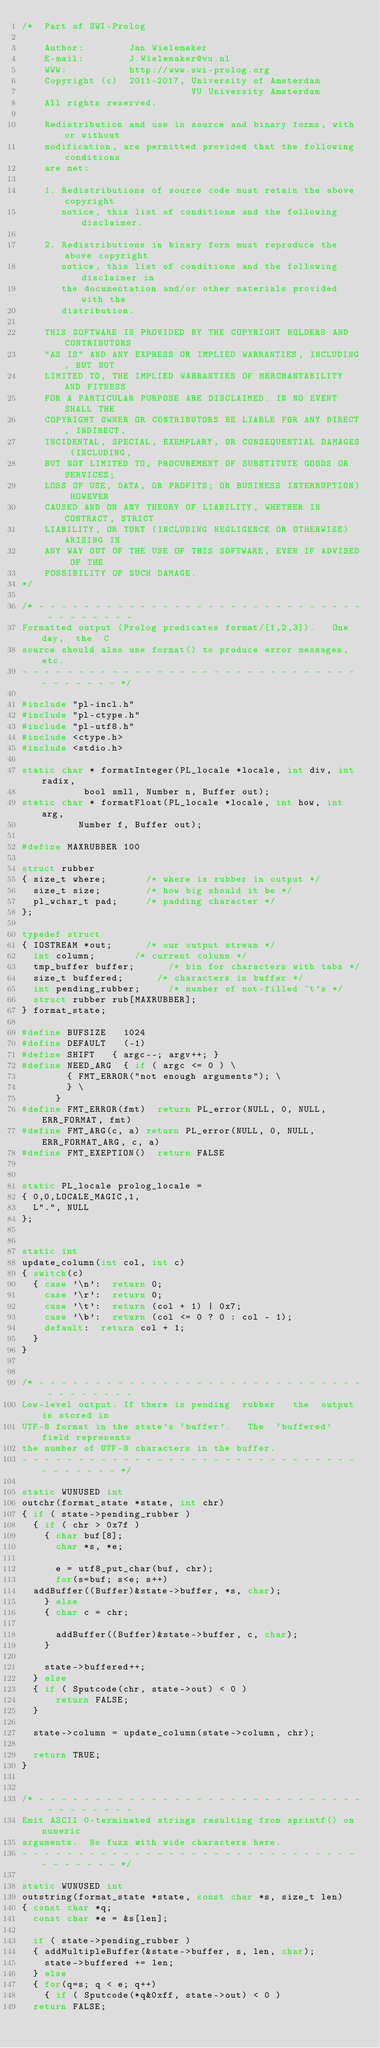Convert code to text. <code><loc_0><loc_0><loc_500><loc_500><_C_>/*  Part of SWI-Prolog

    Author:        Jan Wielemaker
    E-mail:        J.Wielemaker@vu.nl
    WWW:           http://www.swi-prolog.org
    Copyright (c)  2011-2017, University of Amsterdam
                              VU University Amsterdam
    All rights reserved.

    Redistribution and use in source and binary forms, with or without
    modification, are permitted provided that the following conditions
    are met:

    1. Redistributions of source code must retain the above copyright
       notice, this list of conditions and the following disclaimer.

    2. Redistributions in binary form must reproduce the above copyright
       notice, this list of conditions and the following disclaimer in
       the documentation and/or other materials provided with the
       distribution.

    THIS SOFTWARE IS PROVIDED BY THE COPYRIGHT HOLDERS AND CONTRIBUTORS
    "AS IS" AND ANY EXPRESS OR IMPLIED WARRANTIES, INCLUDING, BUT NOT
    LIMITED TO, THE IMPLIED WARRANTIES OF MERCHANTABILITY AND FITNESS
    FOR A PARTICULAR PURPOSE ARE DISCLAIMED. IN NO EVENT SHALL THE
    COPYRIGHT OWNER OR CONTRIBUTORS BE LIABLE FOR ANY DIRECT, INDIRECT,
    INCIDENTAL, SPECIAL, EXEMPLARY, OR CONSEQUENTIAL DAMAGES (INCLUDING,
    BUT NOT LIMITED TO, PROCUREMENT OF SUBSTITUTE GOODS OR SERVICES;
    LOSS OF USE, DATA, OR PROFITS; OR BUSINESS INTERRUPTION) HOWEVER
    CAUSED AND ON ANY THEORY OF LIABILITY, WHETHER IN CONTRACT, STRICT
    LIABILITY, OR TORT (INCLUDING NEGLIGENCE OR OTHERWISE) ARISING IN
    ANY WAY OUT OF THE USE OF THIS SOFTWARE, EVEN IF ADVISED OF THE
    POSSIBILITY OF SUCH DAMAGE.
*/

/* - - - - - - - - - - - - - - - - - - - - - - - - - - - - - - - - - - - - -
Formatted output (Prolog predicates format/[1,2,3]).   One  day,  the  C
source should also use format() to produce error messages, etc.
- - - - - - - - - - - - - - - - - - - - - - - - - - - - - - - - - - - - - */

#include "pl-incl.h"
#include "pl-ctype.h"
#include "pl-utf8.h"
#include <ctype.h>
#include <stdio.h>

static char *	formatInteger(PL_locale *locale, int div, int radix,
			     bool smll, Number n, Buffer out);
static char *	formatFloat(PL_locale *locale, int how, int arg,
			    Number f, Buffer out);

#define MAXRUBBER 100

struct rubber
{ size_t where;				/* where is rubber in output */
  size_t size;				/* how big should it be */
  pl_wchar_t pad;			/* padding character */
};

typedef struct
{ IOSTREAM *out;			/* our output stream */
  int column;				/* current column */
  tmp_buffer buffer;			/* bin for characters with tabs */
  size_t buffered;			/* characters in buffer */
  int pending_rubber;			/* number of not-filled ~t's */
  struct rubber rub[MAXRUBBER];
} format_state;

#define BUFSIZE		1024
#define DEFAULT		(-1)
#define SHIFT		{ argc--; argv++; }
#define NEED_ARG	{ if ( argc <= 0 ) \
			  { FMT_ERROR("not enough arguments"); \
			  } \
			}
#define FMT_ERROR(fmt)	return PL_error(NULL, 0, NULL, ERR_FORMAT, fmt)
#define FMT_ARG(c, a)	return PL_error(NULL, 0, NULL, ERR_FORMAT_ARG, c, a)
#define FMT_EXEPTION()	return FALSE


static PL_locale prolog_locale =
{ 0,0,LOCALE_MAGIC,1,
  L".", NULL
};


static int
update_column(int col, int c)
{ switch(c)
  { case '\n':	return 0;
    case '\r':  return 0;
    case '\t':	return (col + 1) | 0x7;
    case '\b':	return (col <= 0 ? 0 : col - 1);
    default:	return col + 1;
  }
}


/* - - - - - - - - - - - - - - - - - - - - - - - - - - - - - - - - - - - - -
Low-level output. If there is pending  rubber   the  output is stored in
UTF-8 format in the state's `buffer'.   The  `buffered' field represents
the number of UTF-8 characters in the buffer.
- - - - - - - - - - - - - - - - - - - - - - - - - - - - - - - - - - - - - */

static WUNUSED int
outchr(format_state *state, int chr)
{ if ( state->pending_rubber )
  { if ( chr > 0x7f )
    { char buf[8];
      char *s, *e;

      e = utf8_put_char(buf, chr);
      for(s=buf; s<e; s++)
	addBuffer((Buffer)&state->buffer, *s, char);
    } else
    { char c = chr;

      addBuffer((Buffer)&state->buffer, c, char);
    }

    state->buffered++;
  } else
  { if ( Sputcode(chr, state->out) < 0 )
      return FALSE;
  }

  state->column = update_column(state->column, chr);

  return TRUE;
}


/* - - - - - - - - - - - - - - - - - - - - - - - - - - - - - - - - - - - - -
Emit ASCII 0-terminated strings resulting from sprintf() on numeric
arguments.  No fuzz with wide characters here.
- - - - - - - - - - - - - - - - - - - - - - - - - - - - - - - - - - - - - */

static WUNUSED int
outstring(format_state *state, const char *s, size_t len)
{ const char *q;
  const char *e = &s[len];

  if ( state->pending_rubber )
  { addMultipleBuffer(&state->buffer, s, len, char);
    state->buffered += len;
  } else
  { for(q=s; q < e; q++)
    { if ( Sputcode(*q&0xff, state->out) < 0 )
	return FALSE;</code> 